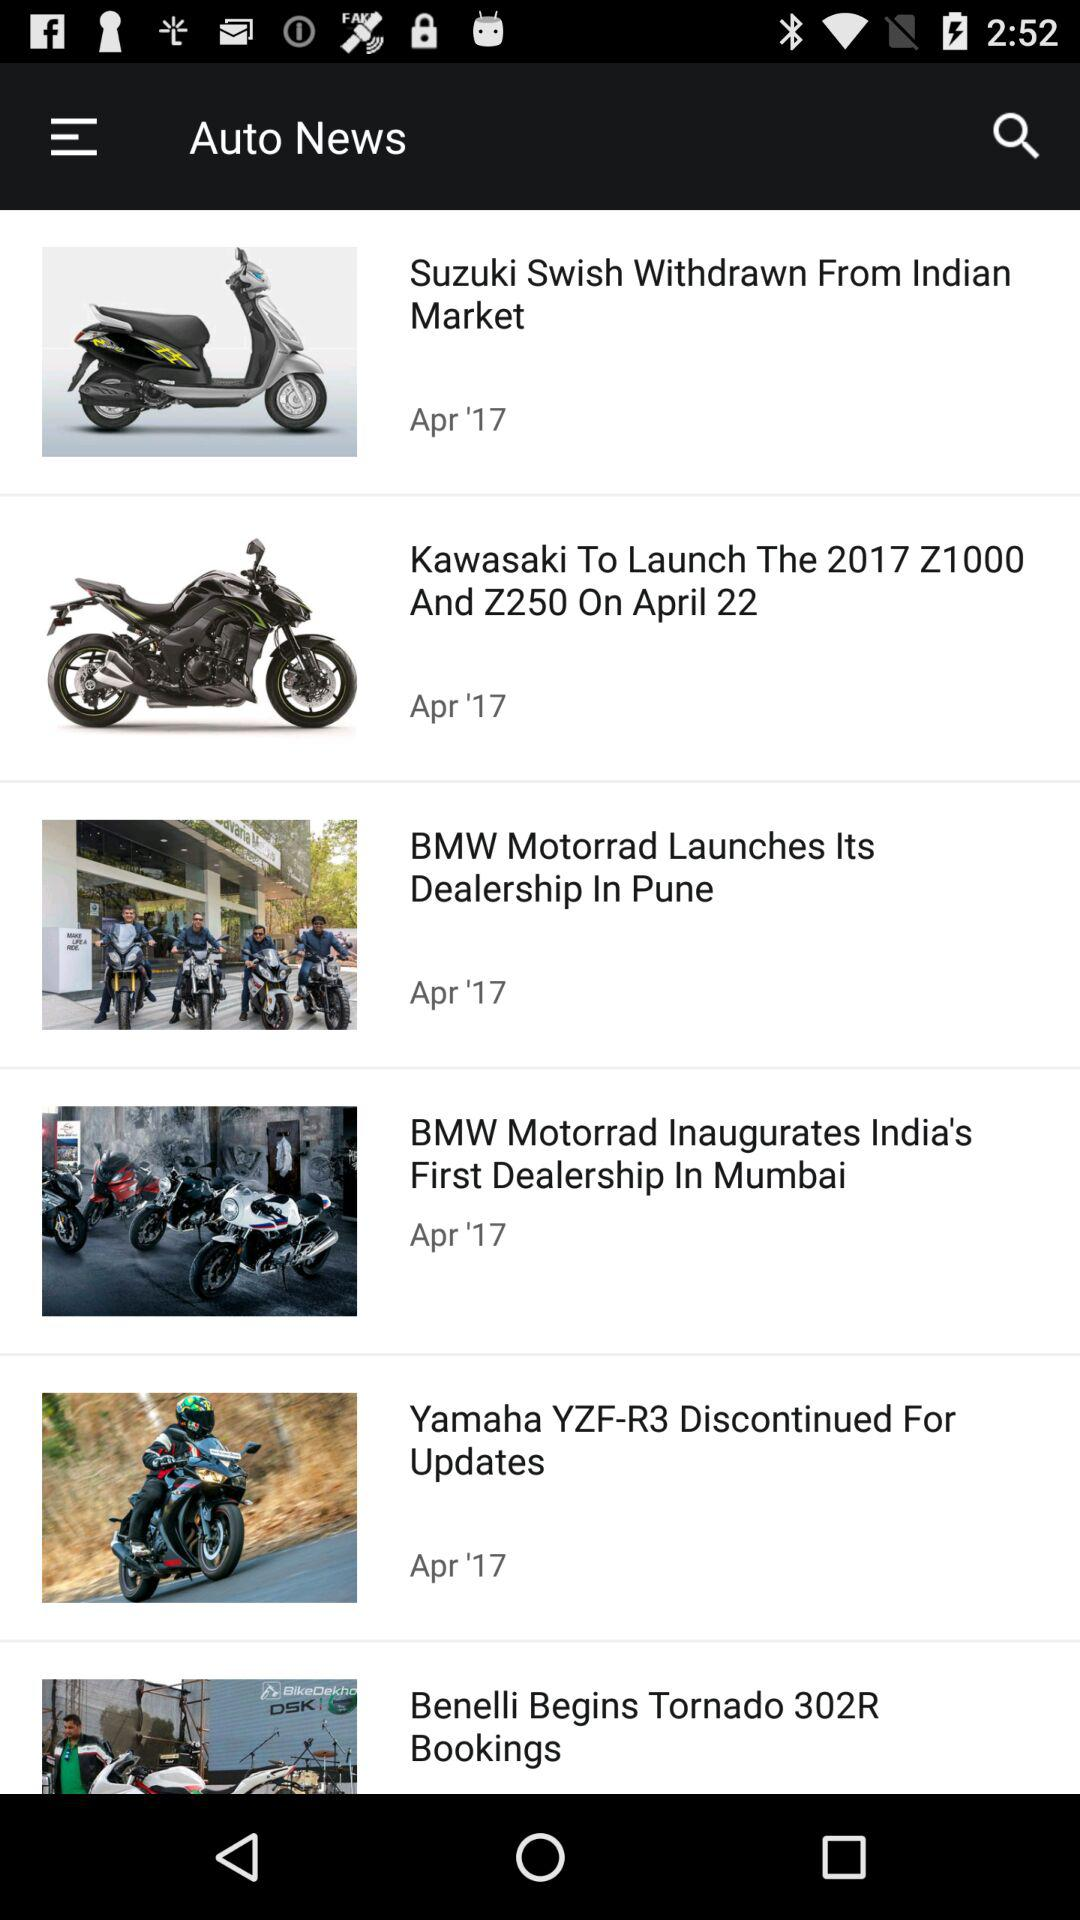When was "BMW Motorrad Launches Its Dealership In Pune" posted? "BMW Motorrad Launches Its Dealership In Pune" was posted on April, 2017. 